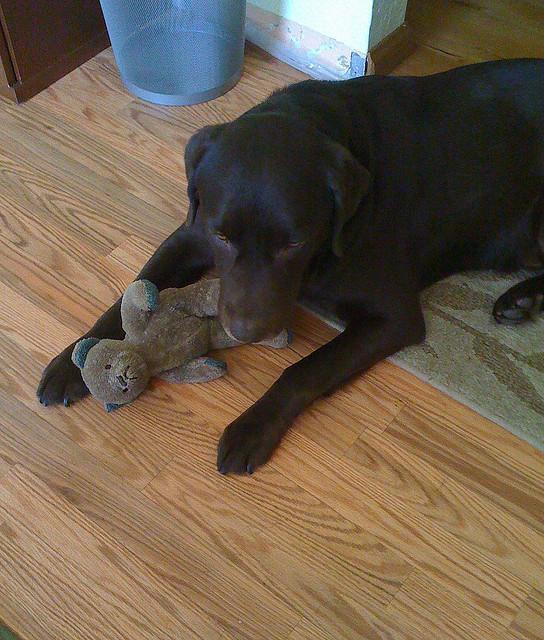How many dogs can be seen?
Give a very brief answer. 1. 